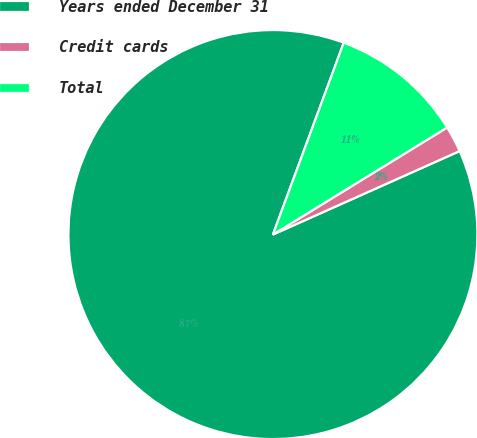Convert chart. <chart><loc_0><loc_0><loc_500><loc_500><pie_chart><fcel>Years ended December 31<fcel>Credit cards<fcel>Total<nl><fcel>87.32%<fcel>2.08%<fcel>10.6%<nl></chart> 